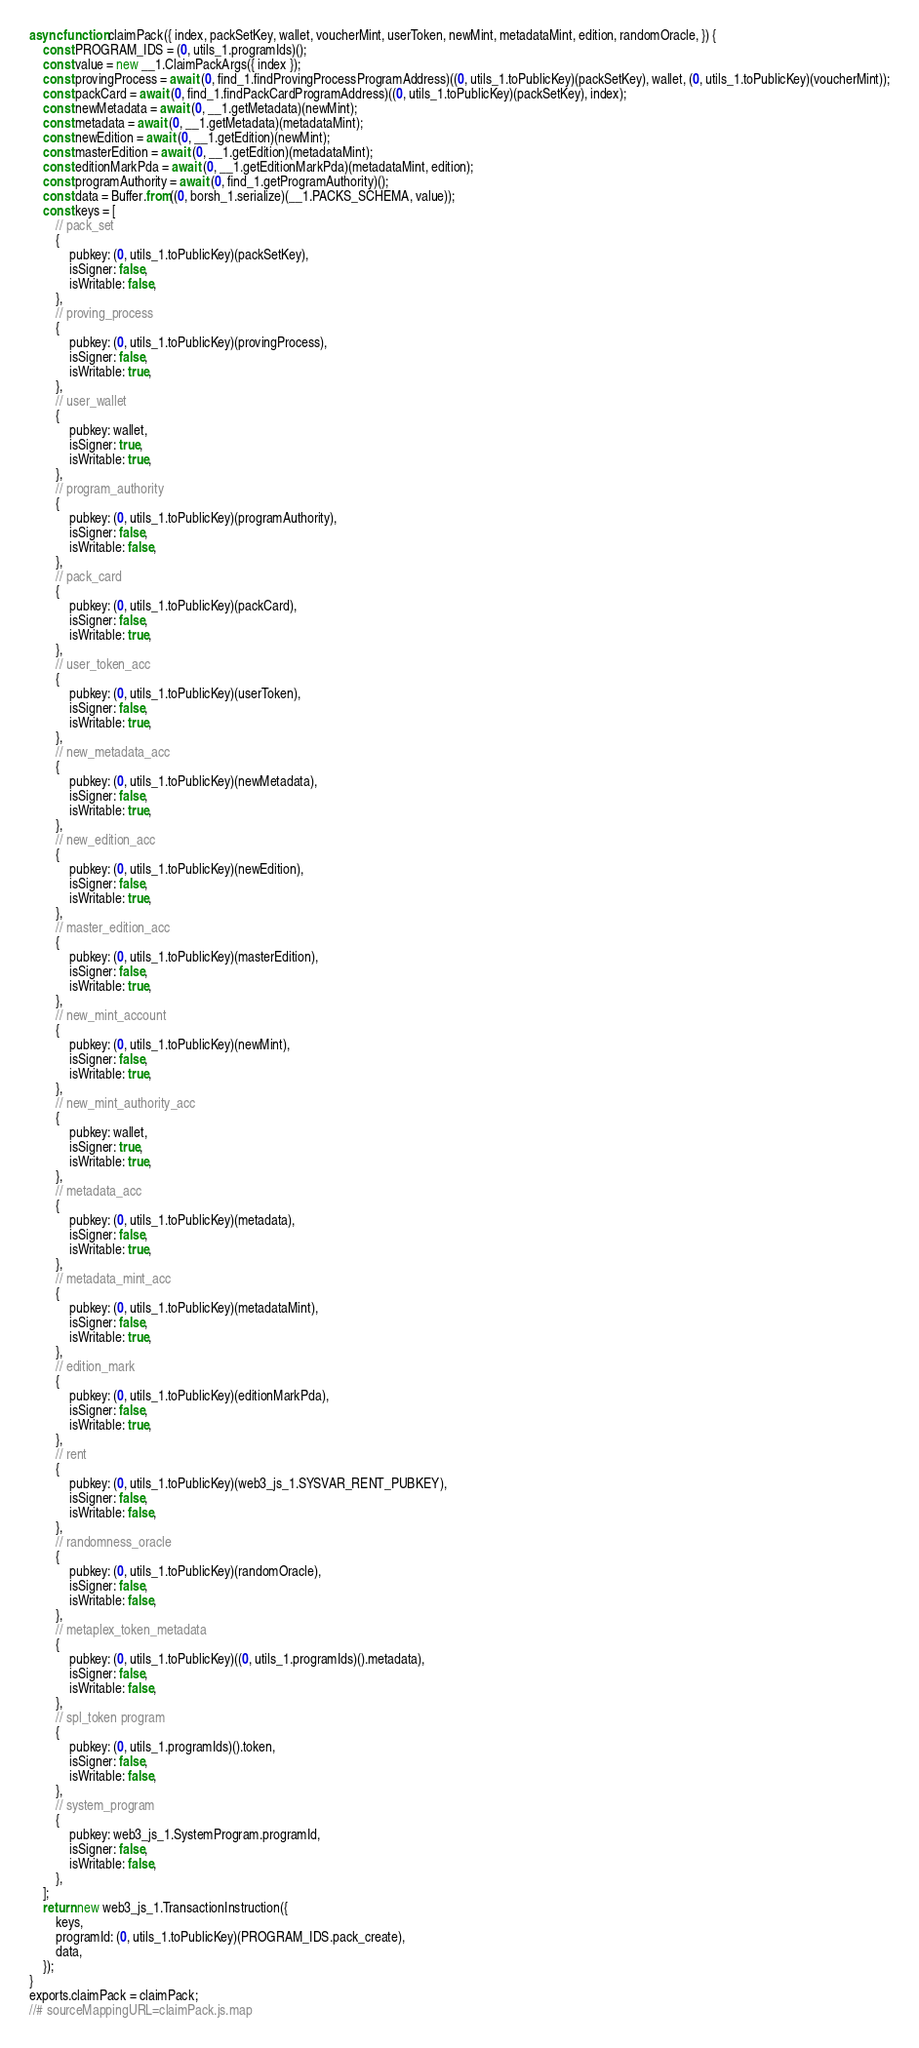<code> <loc_0><loc_0><loc_500><loc_500><_JavaScript_>async function claimPack({ index, packSetKey, wallet, voucherMint, userToken, newMint, metadataMint, edition, randomOracle, }) {
    const PROGRAM_IDS = (0, utils_1.programIds)();
    const value = new __1.ClaimPackArgs({ index });
    const provingProcess = await (0, find_1.findProvingProcessProgramAddress)((0, utils_1.toPublicKey)(packSetKey), wallet, (0, utils_1.toPublicKey)(voucherMint));
    const packCard = await (0, find_1.findPackCardProgramAddress)((0, utils_1.toPublicKey)(packSetKey), index);
    const newMetadata = await (0, __1.getMetadata)(newMint);
    const metadata = await (0, __1.getMetadata)(metadataMint);
    const newEdition = await (0, __1.getEdition)(newMint);
    const masterEdition = await (0, __1.getEdition)(metadataMint);
    const editionMarkPda = await (0, __1.getEditionMarkPda)(metadataMint, edition);
    const programAuthority = await (0, find_1.getProgramAuthority)();
    const data = Buffer.from((0, borsh_1.serialize)(__1.PACKS_SCHEMA, value));
    const keys = [
        // pack_set
        {
            pubkey: (0, utils_1.toPublicKey)(packSetKey),
            isSigner: false,
            isWritable: false,
        },
        // proving_process
        {
            pubkey: (0, utils_1.toPublicKey)(provingProcess),
            isSigner: false,
            isWritable: true,
        },
        // user_wallet
        {
            pubkey: wallet,
            isSigner: true,
            isWritable: true,
        },
        // program_authority
        {
            pubkey: (0, utils_1.toPublicKey)(programAuthority),
            isSigner: false,
            isWritable: false,
        },
        // pack_card
        {
            pubkey: (0, utils_1.toPublicKey)(packCard),
            isSigner: false,
            isWritable: true,
        },
        // user_token_acc
        {
            pubkey: (0, utils_1.toPublicKey)(userToken),
            isSigner: false,
            isWritable: true,
        },
        // new_metadata_acc
        {
            pubkey: (0, utils_1.toPublicKey)(newMetadata),
            isSigner: false,
            isWritable: true,
        },
        // new_edition_acc
        {
            pubkey: (0, utils_1.toPublicKey)(newEdition),
            isSigner: false,
            isWritable: true,
        },
        // master_edition_acc
        {
            pubkey: (0, utils_1.toPublicKey)(masterEdition),
            isSigner: false,
            isWritable: true,
        },
        // new_mint_account
        {
            pubkey: (0, utils_1.toPublicKey)(newMint),
            isSigner: false,
            isWritable: true,
        },
        // new_mint_authority_acc
        {
            pubkey: wallet,
            isSigner: true,
            isWritable: true,
        },
        // metadata_acc
        {
            pubkey: (0, utils_1.toPublicKey)(metadata),
            isSigner: false,
            isWritable: true,
        },
        // metadata_mint_acc
        {
            pubkey: (0, utils_1.toPublicKey)(metadataMint),
            isSigner: false,
            isWritable: true,
        },
        // edition_mark
        {
            pubkey: (0, utils_1.toPublicKey)(editionMarkPda),
            isSigner: false,
            isWritable: true,
        },
        // rent
        {
            pubkey: (0, utils_1.toPublicKey)(web3_js_1.SYSVAR_RENT_PUBKEY),
            isSigner: false,
            isWritable: false,
        },
        // randomness_oracle
        {
            pubkey: (0, utils_1.toPublicKey)(randomOracle),
            isSigner: false,
            isWritable: false,
        },
        // metaplex_token_metadata
        {
            pubkey: (0, utils_1.toPublicKey)((0, utils_1.programIds)().metadata),
            isSigner: false,
            isWritable: false,
        },
        // spl_token program
        {
            pubkey: (0, utils_1.programIds)().token,
            isSigner: false,
            isWritable: false,
        },
        // system_program
        {
            pubkey: web3_js_1.SystemProgram.programId,
            isSigner: false,
            isWritable: false,
        },
    ];
    return new web3_js_1.TransactionInstruction({
        keys,
        programId: (0, utils_1.toPublicKey)(PROGRAM_IDS.pack_create),
        data,
    });
}
exports.claimPack = claimPack;
//# sourceMappingURL=claimPack.js.map</code> 